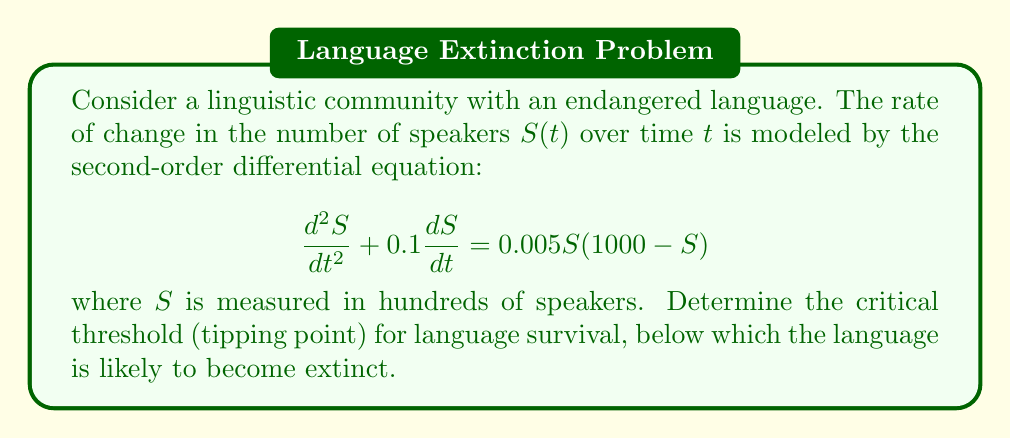Help me with this question. To find the critical threshold for language survival, we need to analyze the equilibrium points of the system and their stability.

1) First, let's rewrite the equation as a system of first-order equations:
   Let $y = \frac{dS}{dt}$, then:
   $$\frac{dS}{dt} = y$$
   $$\frac{dy}{dt} = -0.1y + 0.005S(1000 - S)$$

2) To find equilibrium points, set both derivatives to zero:
   $$y = 0$$
   $$-0.1y + 0.005S(1000 - S) = 0$$

3) Substituting $y = 0$ into the second equation:
   $$0.005S(1000 - S) = 0$$

4) Solving this equation:
   $S = 0$ or $S = 1000$

5) The equilibrium points are $(0, 0)$ and $(1000, 0)$.

6) To determine stability, we need to find the Jacobian matrix:
   $$J = \begin{bmatrix}
   0 & 1 \\
   0.005(1000 - 2S) & -0.1
   \end{bmatrix}$$

7) Evaluate the Jacobian at $(0, 0)$:
   $$J_{(0,0)} = \begin{bmatrix}
   0 & 1 \\
   5 & -0.1
   \end{bmatrix}$$

   The eigenvalues are approximately 2.236 and -2.336.

8) Evaluate the Jacobian at $(1000, 0)$:
   $$J_{(1000,0)} = \begin{bmatrix}
   0 & 1 \\
   -5 & -0.1
   \end{bmatrix}$$

   The eigenvalues are approximately -0.05 ± 2.236i.

9) The equilibrium point $(0, 0)$ is unstable (saddle point), while $(1000, 0)$ is stable (spiral sink).

10) The critical threshold (tipping point) is the unstable manifold of the saddle point $(0, 0)$. To approximate this, we can use the eigenvector corresponding to the positive eigenvalue:

    $$\vec{v} = \begin{bmatrix}
    1 \\
    2.236
    \end{bmatrix}$$

11) This suggests that the critical threshold is approximately when $S = 100$ (since $S$ is measured in hundreds of speakers).
Answer: The critical threshold for language survival is approximately 100 speakers. Below this number, the language is likely to become extinct, while above this number, it has a chance of recovering to the stable equilibrium of 100,000 speakers. 